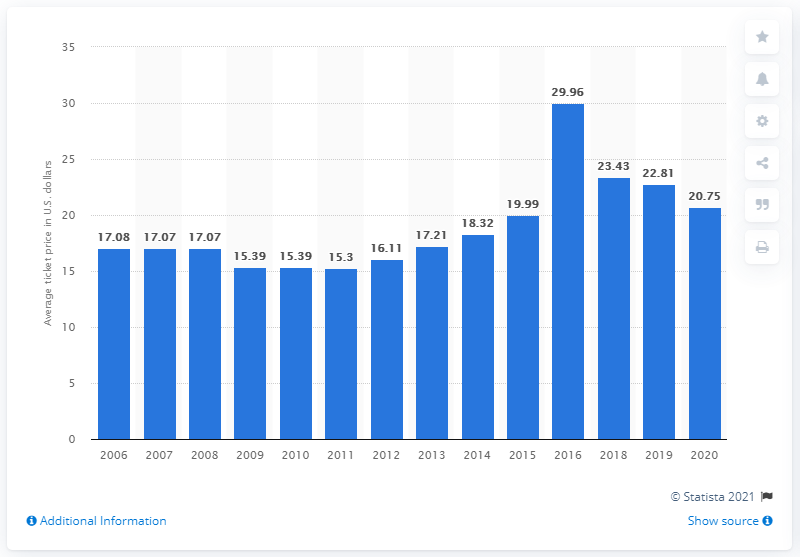Mention a couple of crucial points in this snapshot. The average ticket price for Pittsburgh Pirates games in 2020 was $20.75. 